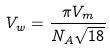<formula> <loc_0><loc_0><loc_500><loc_500>V _ { w } = \frac { \pi V _ { m } } { N _ { A } \sqrt { 1 8 } }</formula> 